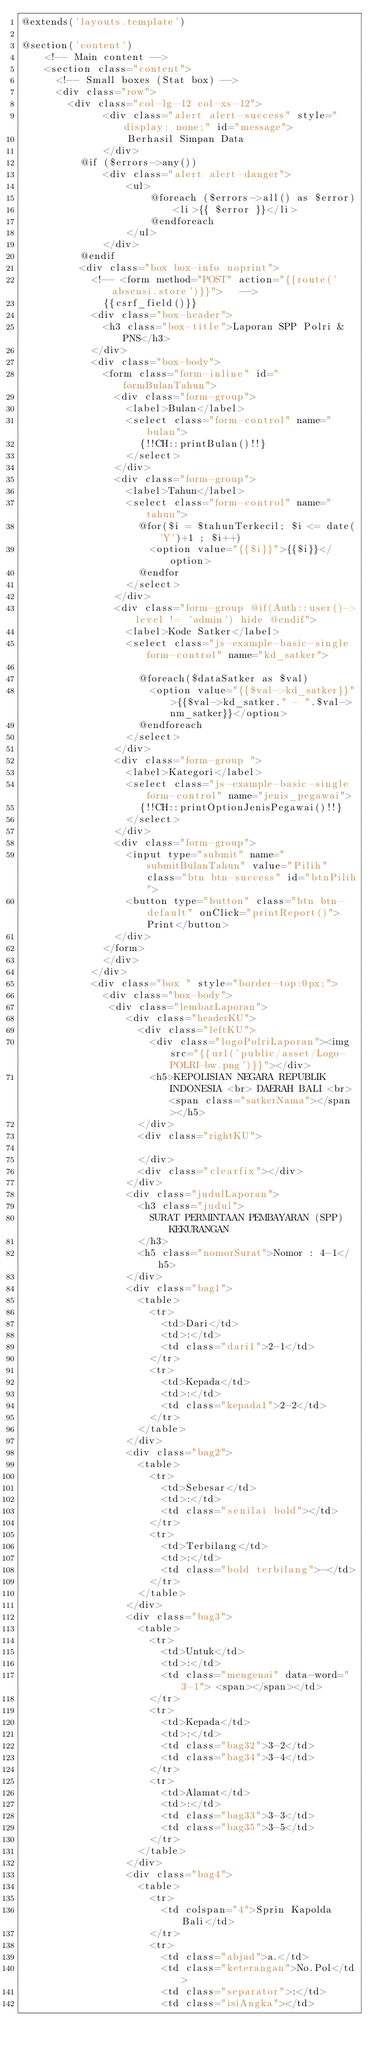Convert code to text. <code><loc_0><loc_0><loc_500><loc_500><_PHP_>@extends('layouts.template')

@section('content')
    <!-- Main content -->
    <section class="content">
      <!-- Small boxes (Stat box) -->
      <div class="row">
        <div class="col-lg-12 col-xs-12">         
              <div class="alert alert-success" style="display: none;" id="message">
                  Berhasil Simpan Data
              </div>          
          @if ($errors->any())
              <div class="alert alert-danger">
                  <ul>
                      @foreach ($errors->all() as $error)
                          <li>{{ $error }}</li>
                      @endforeach
                  </ul>
              </div>
          @endif
          <div class="box box-info noprint">
            <!-- <form method="POST" action="{{route('absensi.store')}}">   -->
              {{csrf_field()}}
            <div class="box-header">              
              <h3 class="box-title">Laporan SPP Polri & PNS</h3>                            
            </div>
            <div class="box-body">    
              <form class="form-inline" id="formBulanTahun">
                <div class="form-group">
                  <label>Bulan</label>
                  <select class="form-control" name="bulan">
                    {!!CH::printBulan()!!}
                  </select>
                </div>
                <div class="form-group">
                  <label>Tahun</label>
                  <select class="form-control" name="tahun">
                    @for($i = $tahunTerkecil; $i <= date('Y')+1 ; $i++)
                      <option value="{{$i}}">{{$i}}</option>
                    @endfor
                  </select>
                </div>
                <div class="form-group @if(Auth::user()->level != 'admin') hide @endif">
                  <label>Kode Satker</label>
                  <select class="js-example-basic-single form-control" name="kd_satker">    
                                 
                    @foreach($dataSatker as $val)
                      <option value="{{$val->kd_satker}}">{{$val->kd_satker." - ".$val->nm_satker}}</option>                  
                    @endforeach
                  </select>                 
                </div>              
                <div class="form-group ">
                  <label>Kategori</label>
                  <select class="js-example-basic-single form-control" name="jenis_pegawai">    
                    {!!CH::printOptionJenisPegawai()!!}             
                  </select>                 
                </div>  
                <div class="form-group">
                  <input type="submit" name="submitBulanTahun" value="Pilih" class="btn btn-success" id="btnPilih">
                  <button type="button" class="btn btn-default" onClick="printReport()">Print</button>
                </div>
              </form>
              </div>
            </div>
            <div class="box " style="border-top:0px;">    
              <div class="box-body">
               <div class="lembarLaporan">             
                  <div class="headerKU">
                    <div class="leftKU">
                      <div class="logoPolriLaporan"><img src="{{url('public/asset/Logo-POLRI-bw.png')}}"></div>
                      <h5>KEPOLISIAN NEGARA REPUBLIK INDONESIA <br> DAERAH BALI <br> <span class="satkerNama"></span></h5>
                    </div>
                    <div class="rightKU">
                      
                    </div>
                    <div class="clearfix"></div>
                  </div>
                  <div class="judulLaporan">
                    <h3 class="judul">
                      SURAT PERMINTAAN PEMBAYARAN (SPP) KEKURANGAN 
                    </h3>
                    <h5 class="nomorSurat">Nomor : 4-1</h5>
                  </div>
                  <div class="bag1">
                    <table>
                      <tr>
                        <td>Dari</td>
                        <td>:</td>
                        <td class="dari1">2-1</td>
                      </tr>
                      <tr>
                        <td>Kepada</td>
                        <td>:</td>
                        <td class="kepada1">2-2</td>
                      </tr>
                    </table>
                  </div>
                  <div class="bag2">
                    <table>
                      <tr>
                        <td>Sebesar</td>
                        <td>:</td>
                        <td class="senilai bold"></td>
                      </tr>
                      <tr>
                        <td>Terbilang</td>
                        <td>:</td>
                        <td class="bold terbilang">-</td>
                      </tr>
                    </table>
                  </div>
                  <div class="bag3">
                    <table>
                      <tr>
                        <td>Untuk</td>
                        <td>:</td>
                        <td class="mengenai" data-word="3-1"> <span></span></td>
                      </tr>
                      <tr>
                        <td>Kepada</td>
                        <td>:</td>
                        <td class="bag32">3-2</td>
                        <td class="bag34">3-4</td>
                      </tr>
                      <tr>
                        <td>Alamat</td>
                        <td>:</td>
                        <td class="bag33">3-3</td>
                        <td class="bag35">3-5</td>
                      </tr>
                    </table>
                  </div>
                  <div class="bag4">
                    <table>
                      <tr>
                        <td colspan="4">Sprin Kapolda Bali</td>
                      </tr>
                      <tr>
                        <td class="abjad">a.</td>
                        <td class="keterangan">No.Pol</td>
                        <td class="separator">:</td>
                        <td class="isiAngka"></td></code> 